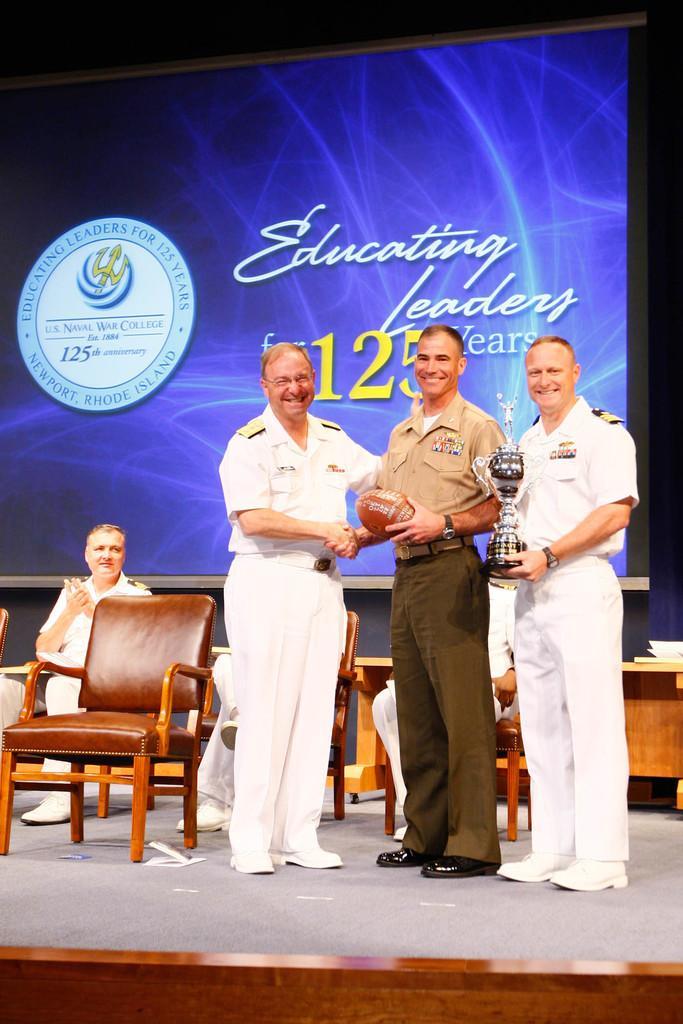How would you summarize this image in a sentence or two? There are three members standing on the stage. One of the guy is holding a trophy and the middle one is holding a ball in their hands. There are some chairs and some of them were sitting in them. In the background there is a display screen here. 